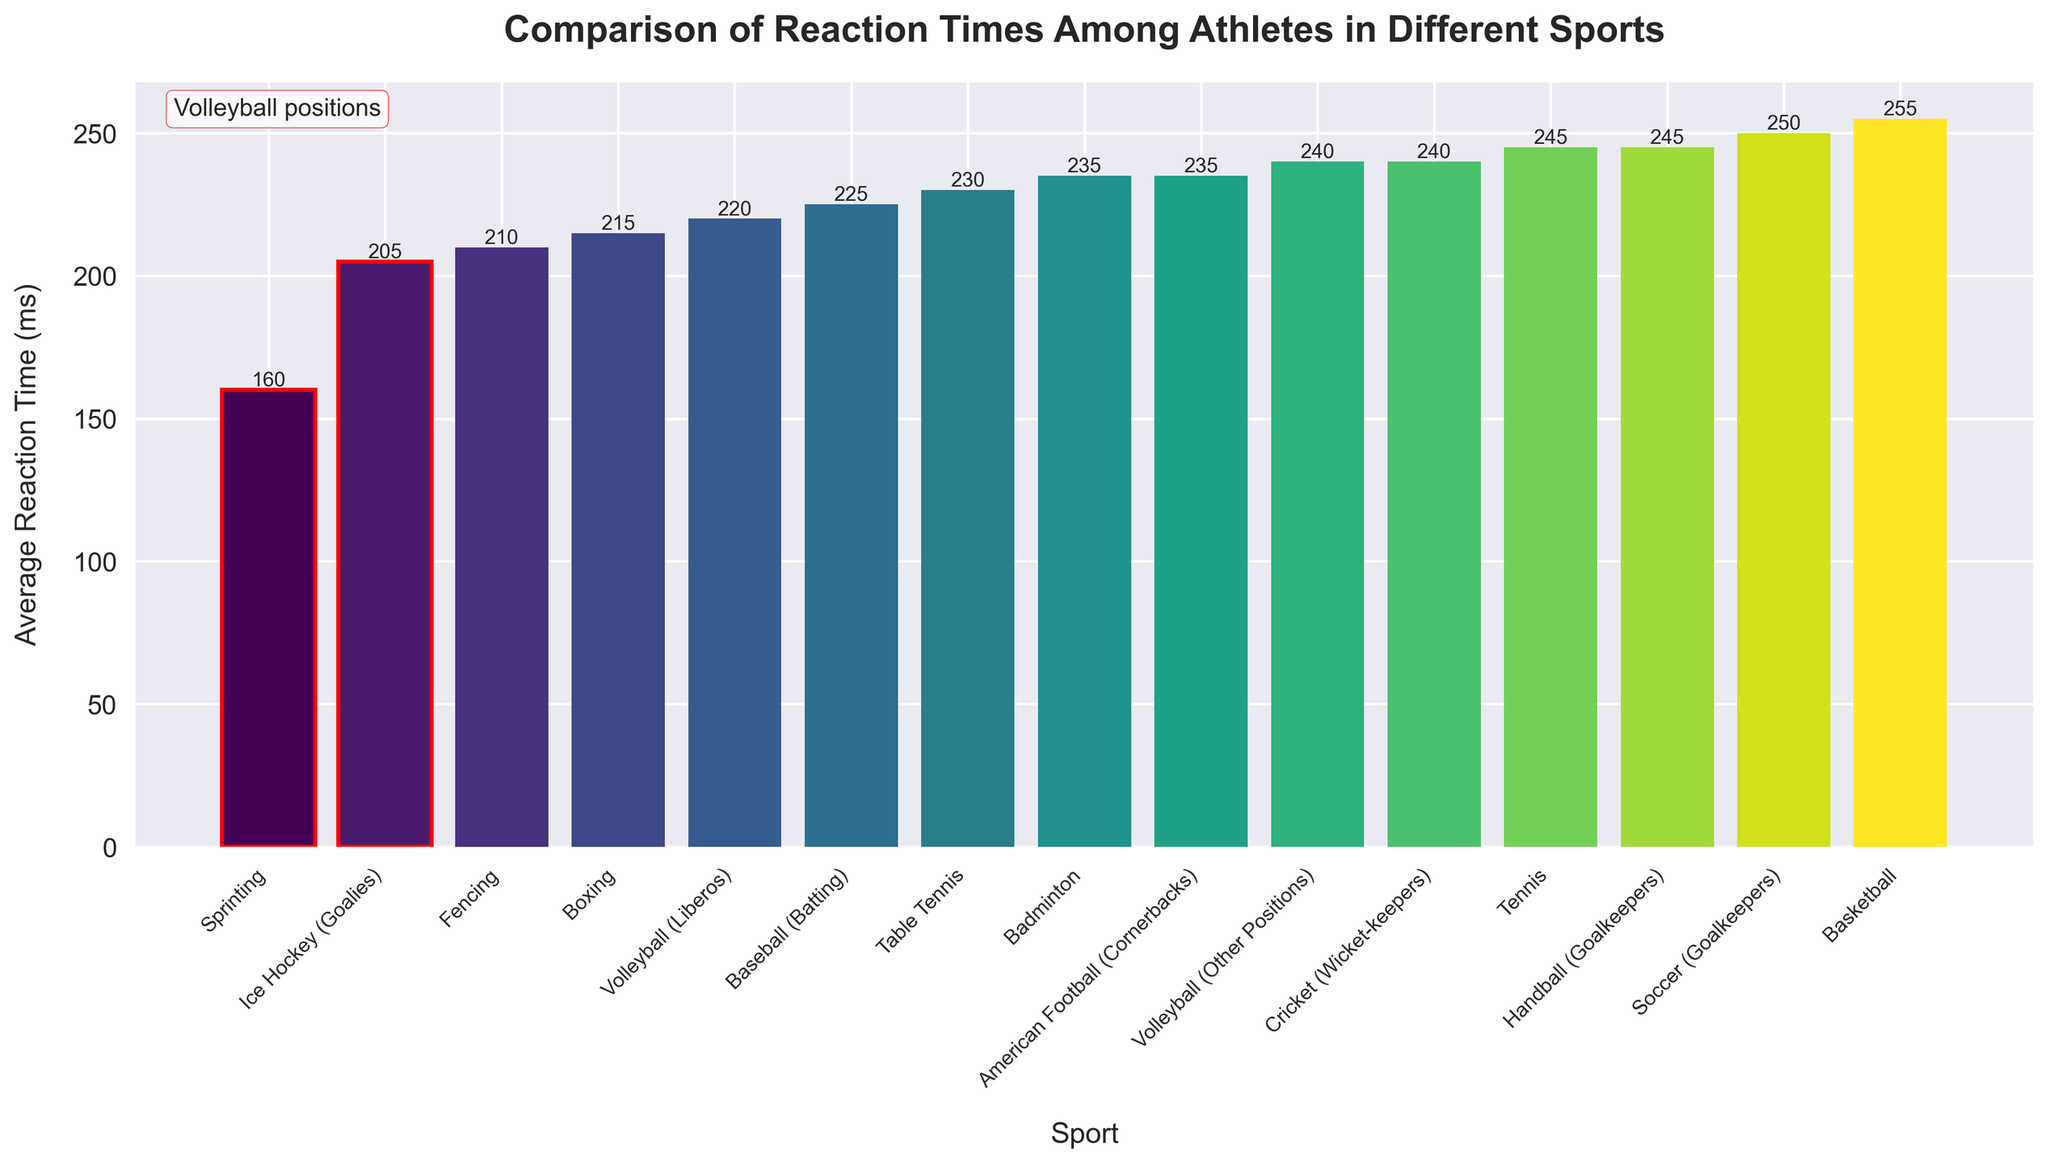What sport has the fastest average reaction time? The sport with the fastest average reaction time is identified by the shortest bar in the chart. Here, it is identified as Sprinting with the reaction time value at the minimum position.
Answer: Sprinting Which group within volleyball players has a faster average reaction time? The chart differentiates volleyball players into two groups: Liberos and Other Positions. Comparing the heights of these specific bars shows that Liberos have a faster reaction time (shorter bar).
Answer: Volleyball (Liberos) Which sport has a worse reaction time than Volleyball (Other Positions) but better than Soccer (Goalkeepers)? To find this, we identify the sports that have an average reaction time falling between 240 ms (Volleyball (Other Positions)) and 250 ms (Soccer (Goalkeepers)) by comparing related bar heights. The sport here is Tennis with an average reaction time of 245 ms.
Answer: Tennis Are there more sports with an average reaction time below 230 ms or above 230 ms? Count the sports with bars lower than 230 ms and those higher. There are 7 sports below 230 ms and 8 sports above. Thus, there are more sports with reaction times above 230 ms.
Answer: Above 230 ms How many sports have a faster reaction time than Volleyball (Liberos)? Identify the bars shorter than the bar representing Volleyball (Liberos), which is at 220 ms. Here, the sports are fencing, ice hockey, boxing, and sprinting, making a total of 4 sports.
Answer: 4 Which is the closest competitor to Volleyball (Liberos) in terms of reaction time, and what is their reaction time? Look for the bars closest in height to Volleyball (Liberos) on either side. The closest is baseball (batting) with 225 ms.
Answer: Baseball (Batting) - 225 ms What is the average reaction time in volleyball including both Liberos and Other Positions? Combine the reaction times of Volleyball (Liberos) and Volleyball (Other Positions) and divide by 2. (220 ms + 240 ms) / 2 = 230 ms.
Answer: 230 ms Which sport is highlighted with red boundaries other than those involving volleyball? The question implies checking if other bars are highlighted similarly to those labeled volleyball. Only Volleyball (Liberos) and Volleyball (Other Positions) are highlighted red, so there is no other sport.
Answer: None What proportion of the visualized sports have a reaction time faster than the reaction time of Volleyball (Other Positions)? Count the sports having reaction times below 240 ms and divide by the total number of sports. Steps: 1. Count the sports (unique bars) below 240 ms (Boxing, Fencing, Ice Hockey, Baseball, Table Tennis), totalling 5. 2. There are 14 sports visualized. So, the proportion is 5/14.
Answer: 5/14 